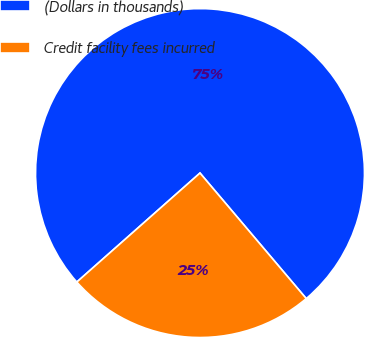Convert chart. <chart><loc_0><loc_0><loc_500><loc_500><pie_chart><fcel>(Dollars in thousands)<fcel>Credit facility fees incurred<nl><fcel>75.35%<fcel>24.65%<nl></chart> 